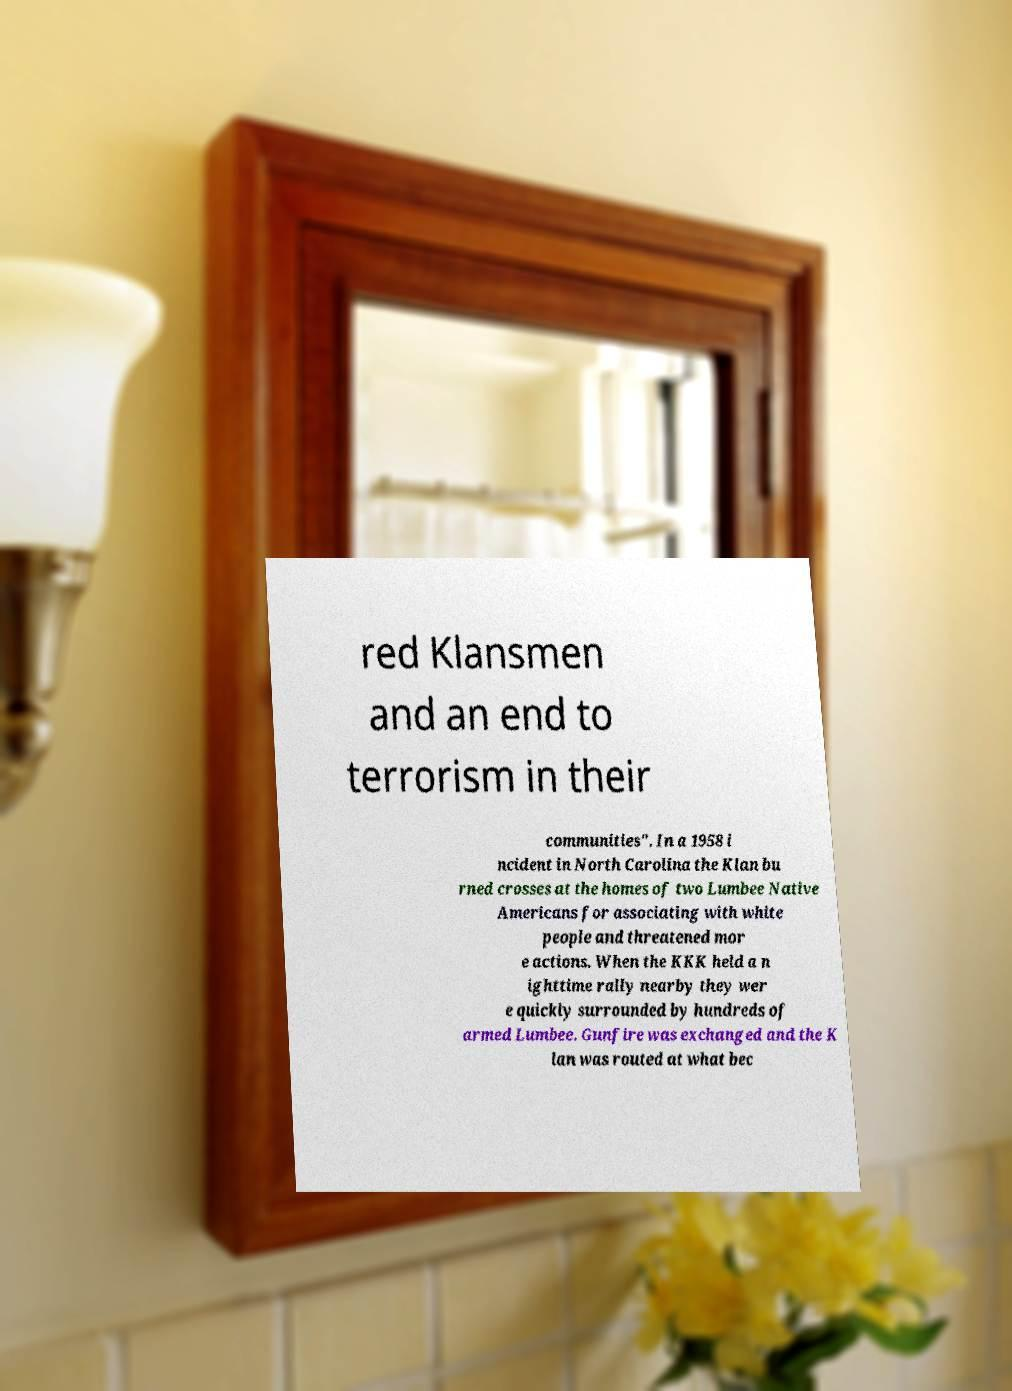For documentation purposes, I need the text within this image transcribed. Could you provide that? red Klansmen and an end to terrorism in their communities". In a 1958 i ncident in North Carolina the Klan bu rned crosses at the homes of two Lumbee Native Americans for associating with white people and threatened mor e actions. When the KKK held a n ighttime rally nearby they wer e quickly surrounded by hundreds of armed Lumbee. Gunfire was exchanged and the K lan was routed at what bec 